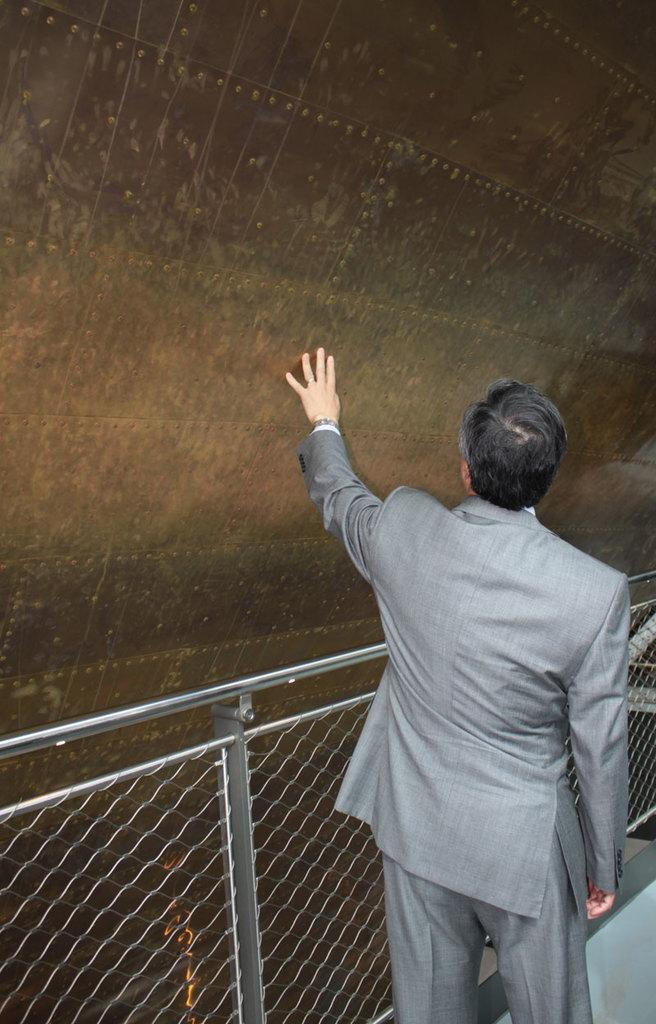What is the person in the image doing? The person is standing beside the metal grill. What can be seen in the background of the image? There is a wall in the background of the image. What type of cub is playing with the soap in the image? There is no cub or soap present in the image. What color is the ink on the person's hands in the image? There is no ink visible on the person's hands in the image. 